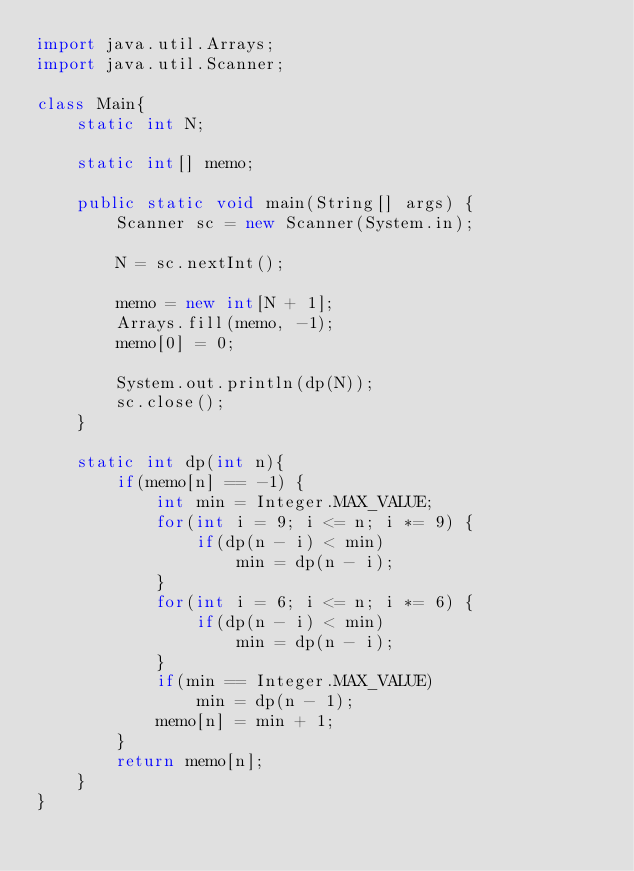Convert code to text. <code><loc_0><loc_0><loc_500><loc_500><_Java_>import java.util.Arrays;
import java.util.Scanner;

class Main{
	static int N;

	static int[] memo;

	public static void main(String[] args) {
		Scanner sc = new Scanner(System.in);

		N = sc.nextInt();

		memo = new int[N + 1];
		Arrays.fill(memo, -1);
		memo[0] = 0;

		System.out.println(dp(N));
		sc.close();
	}

	static int dp(int n){
		if(memo[n] == -1) {
			int min = Integer.MAX_VALUE;
			for(int i = 9; i <= n; i *= 9) {
				if(dp(n - i) < min)
					min = dp(n - i);
			}
			for(int i = 6; i <= n; i *= 6) {
				if(dp(n - i) < min)
					min = dp(n - i);
			}
			if(min == Integer.MAX_VALUE)
				min = dp(n - 1);
			memo[n] = min + 1;
		}
		return memo[n];
	}
}</code> 